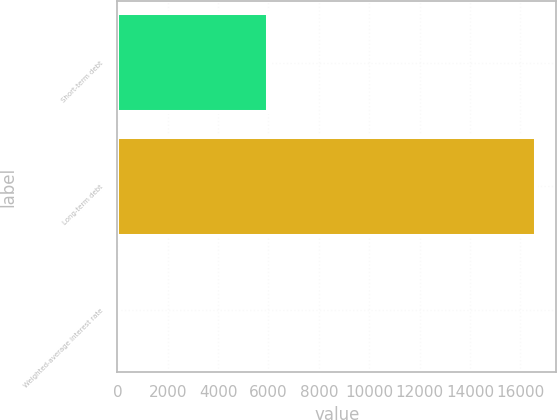<chart> <loc_0><loc_0><loc_500><loc_500><bar_chart><fcel>Short-term debt<fcel>Long-term debt<fcel>Weighted-average interest rate<nl><fcel>5979<fcel>16608<fcel>3<nl></chart> 